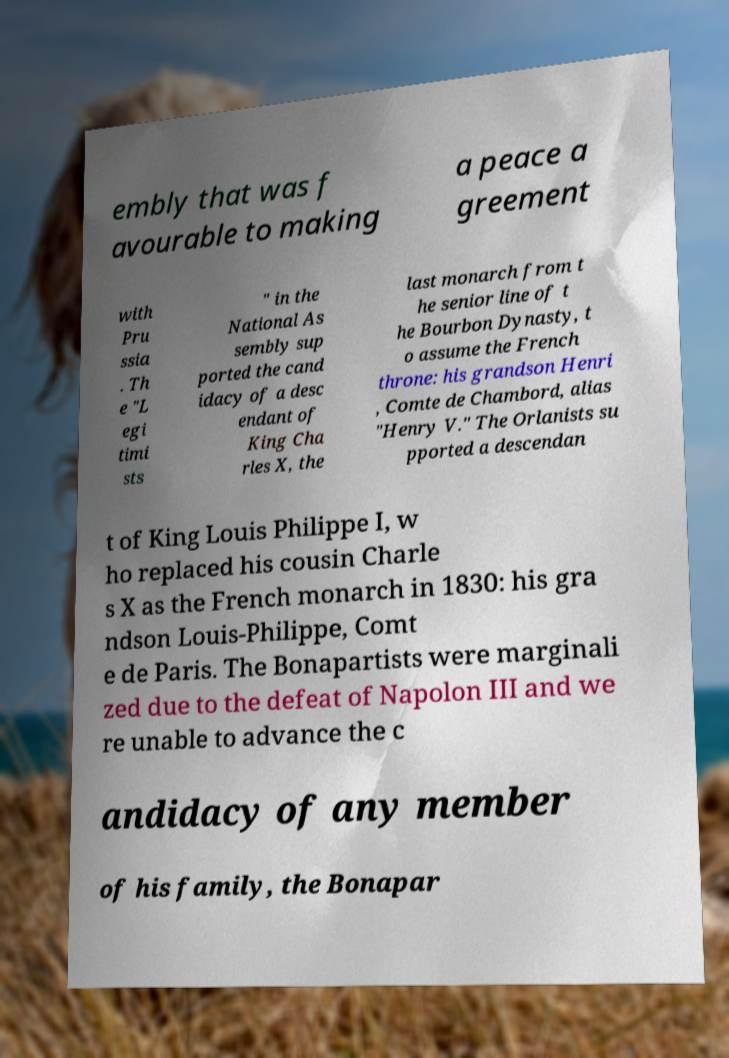What messages or text are displayed in this image? I need them in a readable, typed format. embly that was f avourable to making a peace a greement with Pru ssia . Th e "L egi timi sts " in the National As sembly sup ported the cand idacy of a desc endant of King Cha rles X, the last monarch from t he senior line of t he Bourbon Dynasty, t o assume the French throne: his grandson Henri , Comte de Chambord, alias "Henry V." The Orlanists su pported a descendan t of King Louis Philippe I, w ho replaced his cousin Charle s X as the French monarch in 1830: his gra ndson Louis-Philippe, Comt e de Paris. The Bonapartists were marginali zed due to the defeat of Napolon III and we re unable to advance the c andidacy of any member of his family, the Bonapar 